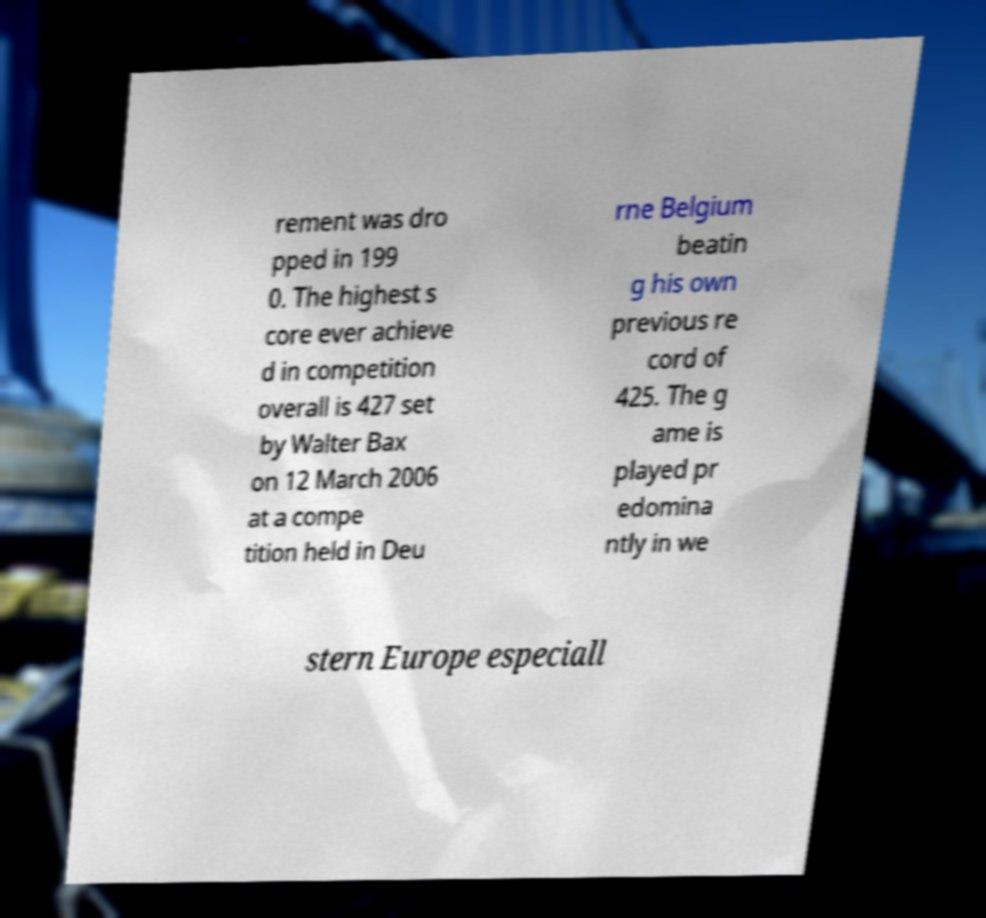Please identify and transcribe the text found in this image. rement was dro pped in 199 0. The highest s core ever achieve d in competition overall is 427 set by Walter Bax on 12 March 2006 at a compe tition held in Deu rne Belgium beatin g his own previous re cord of 425. The g ame is played pr edomina ntly in we stern Europe especiall 